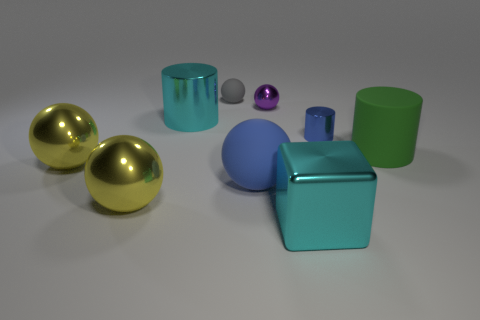Add 1 cyan metal cylinders. How many objects exist? 10 Subtract all tiny blue cylinders. How many cylinders are left? 2 Subtract all blue cylinders. How many yellow balls are left? 2 Subtract all cyan cylinders. How many cylinders are left? 2 Subtract all purple spheres. Subtract all gray cubes. How many spheres are left? 4 Add 9 gray matte spheres. How many gray matte spheres are left? 10 Add 3 large cyan cubes. How many large cyan cubes exist? 4 Subtract 0 gray cylinders. How many objects are left? 9 Subtract all balls. How many objects are left? 4 Subtract 2 cylinders. How many cylinders are left? 1 